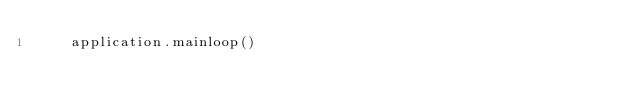Convert code to text. <code><loc_0><loc_0><loc_500><loc_500><_Python_>    application.mainloop()















</code> 